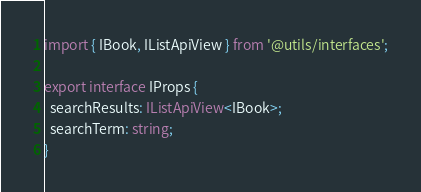Convert code to text. <code><loc_0><loc_0><loc_500><loc_500><_TypeScript_>import { IBook, IListApiView } from '@utils/interfaces';

export interface IProps {
  searchResults: IListApiView<IBook>;
  searchTerm: string;
}
</code> 